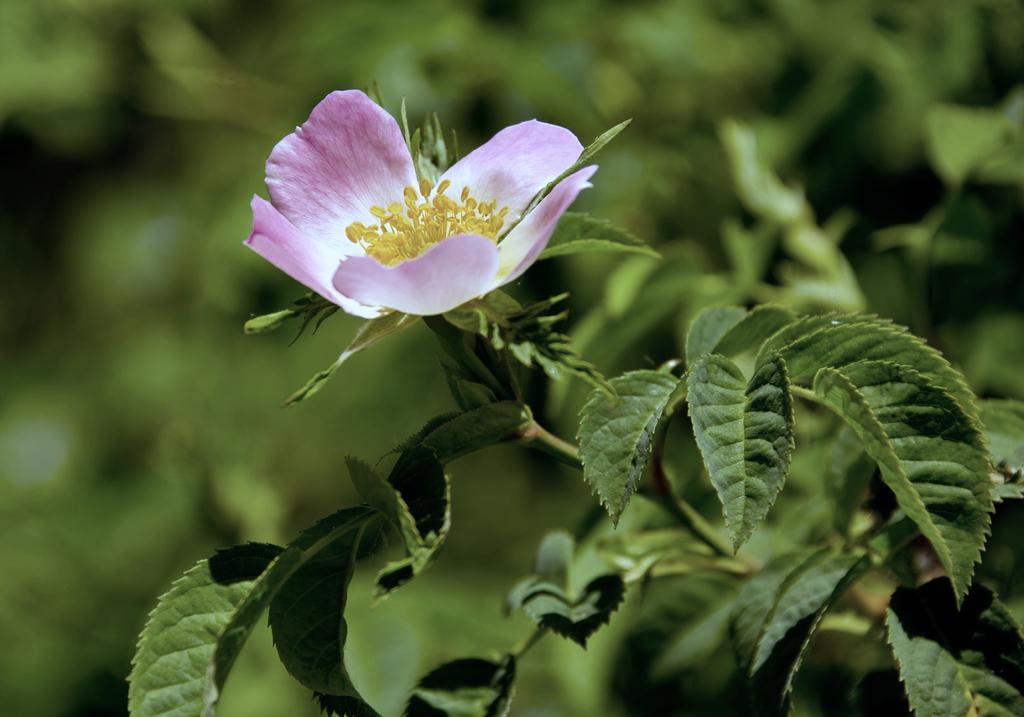What is present on the branch of the plant in the image? There is a flower on the branch of a plant in the image. Where is the plant located in the image? The plant is on the right side of the image. What can be seen at the bottom of the image? Leaves are visible at the bottom of the image. What type of mitten is being used to draw on the chalkboard in the image? There is no mitten or chalkboard present in the image; it features a flower on a plant branch. How are the scissors being used in the image? There are no scissors present in the image. 